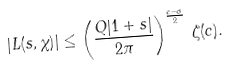<formula> <loc_0><loc_0><loc_500><loc_500>| L ( s , \chi ) | \leq \left ( \frac { Q | 1 + s | } { 2 \pi } \right ) ^ { \frac { c - \sigma } { 2 } } \, \zeta ( c ) .</formula> 